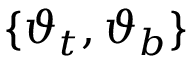<formula> <loc_0><loc_0><loc_500><loc_500>\{ \vartheta _ { t } , \vartheta _ { b } \}</formula> 